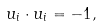<formula> <loc_0><loc_0><loc_500><loc_500>u _ { i } \cdot u _ { i } = - 1 ,</formula> 